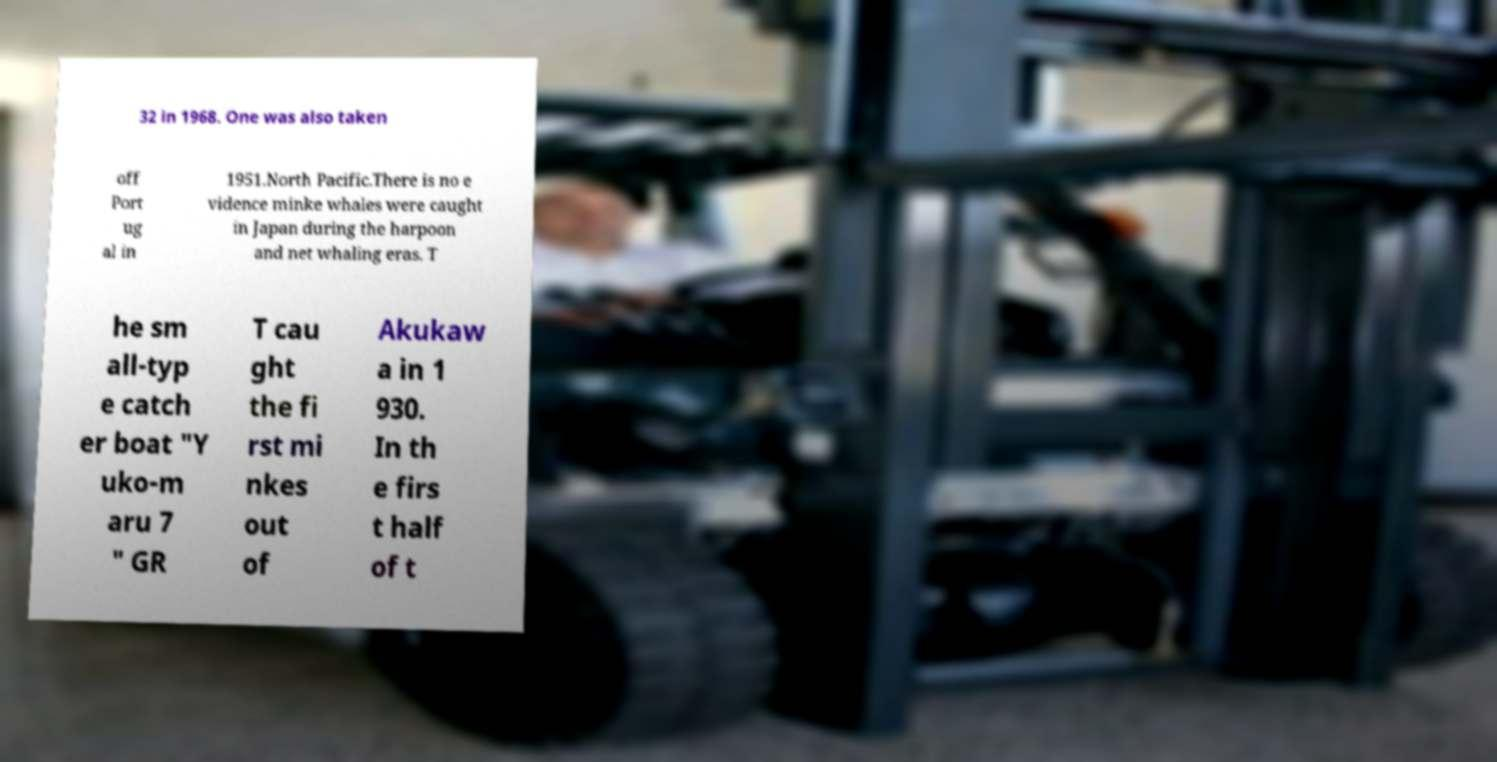Please identify and transcribe the text found in this image. 32 in 1968. One was also taken off Port ug al in 1951.North Pacific.There is no e vidence minke whales were caught in Japan during the harpoon and net whaling eras. T he sm all-typ e catch er boat "Y uko-m aru 7 " GR T cau ght the fi rst mi nkes out of Akukaw a in 1 930. In th e firs t half of t 